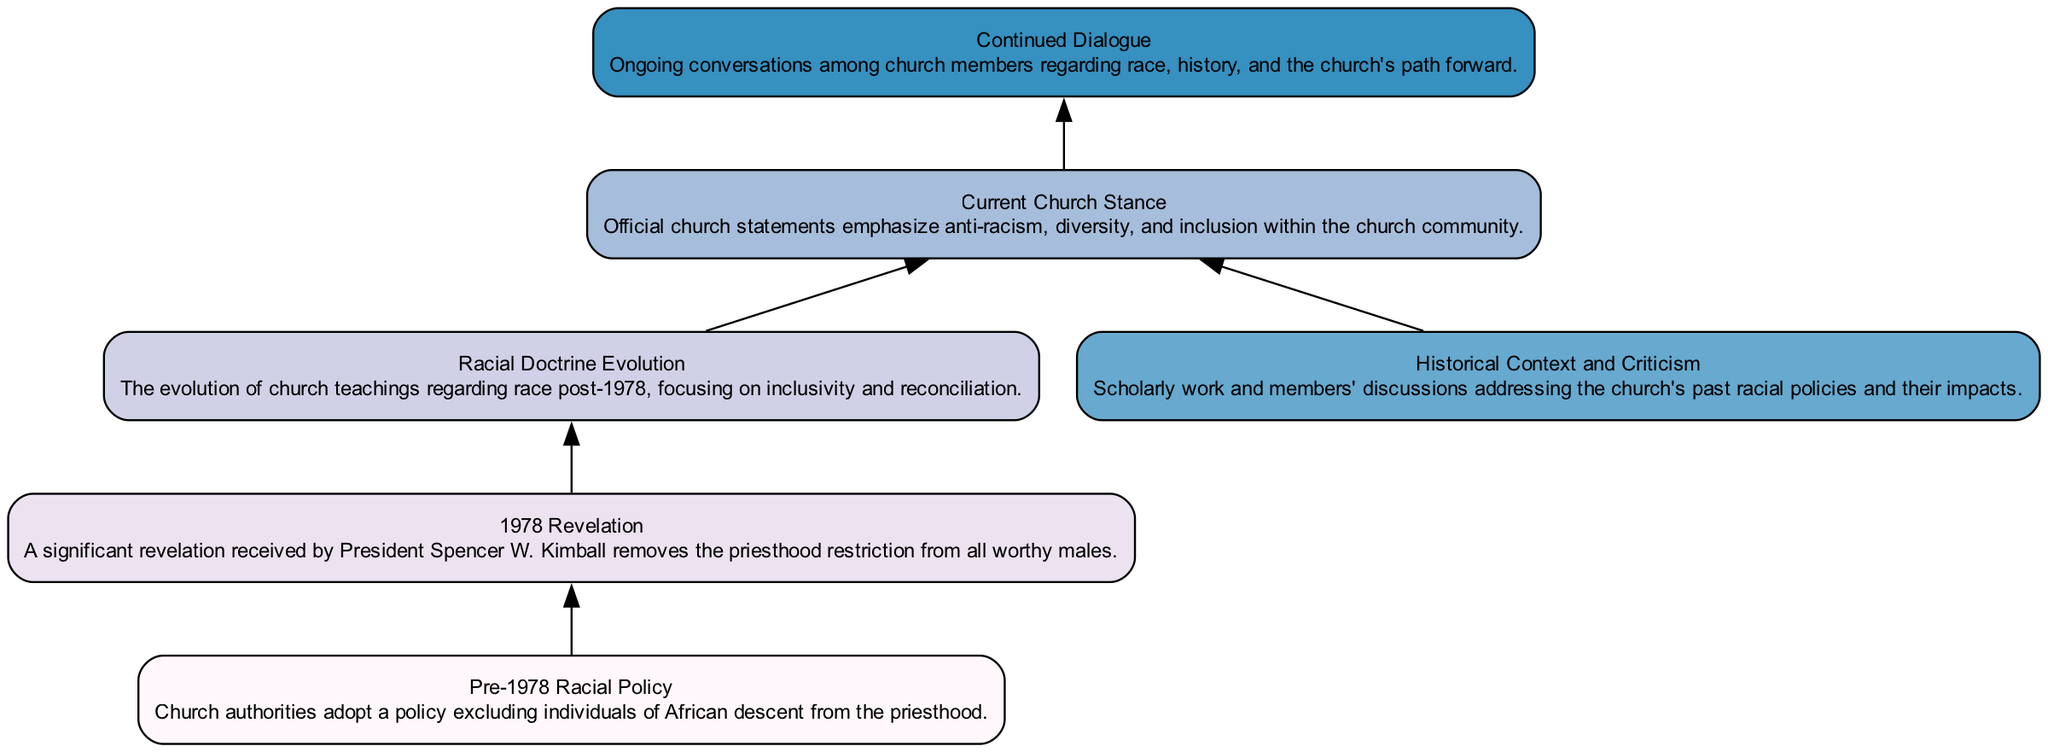What is the first node in the diagram? The first node is labeled "Pre-1978 Racial Policy," which represents the initial policy of the church regarding race.
Answer: Pre-1978 Racial Policy How many nodes are in the diagram? There are a total of six nodes in the diagram, each representing different stages or aspects of the racial policy evolution within the LDS Church.
Answer: 6 What node follows "1978 Revelation"? The node that follows "1978 Revelation" is "Racial Doctrine Evolution," indicating the transition from the revelation to changes in church teachings.
Answer: Racial Doctrine Evolution Which nodes are directly connected to "Current Church Stance"? Directly connected to "Current Church Stance" are "Racial Doctrine Evolution" and "Historical Context and Criticism," showing the sources that contribute to the current perspective.
Answer: Racial Doctrine Evolution, Historical Context and Criticism What does the "1978 Revelation" represent in the diagram? The "1978 Revelation" represents a significant change in church policy, removing the priesthood restriction for all worthy males, marking a pivotal moment in this evolution.
Answer: A significant revelation What is the relationship between "Historical Context and Criticism" and "Current Church Stance"? "Historical Context and Criticism" informs or contributes to the "Current Church Stance," suggesting that discussions about the past influence present policies and beliefs within the church.
Answer: Contributes to Describe the flow from "Pre-1978 Racial Policy" to "Continued Dialogue." The flow starts with "Pre-1978 Racial Policy," which leads to "1978 Revelation," then to "Racial Doctrine Evolution," which progresses to "Current Church Stance," ultimately culminating in "Continued Dialogue." This indicates a significant progression from exclusion to ongoing conversations about race.
Answer: From exclusion to conversation What thematic change is reflected in "Current Church Stance" compared to "Pre-1978 Racial Policy"? The thematic change reflects a shift from exclusionary practices to an emphasis on anti-racism, diversity, and inclusion, indicating a fundamental change in church attitudes towards race.
Answer: Inclusion and anti-racism What is the final step in the evolutionary path presented in the diagram? The final step in the evolutionary path is "Continued Dialogue," representing the ongoing discussions and reflections among church members about race and history.
Answer: Continued Dialogue 